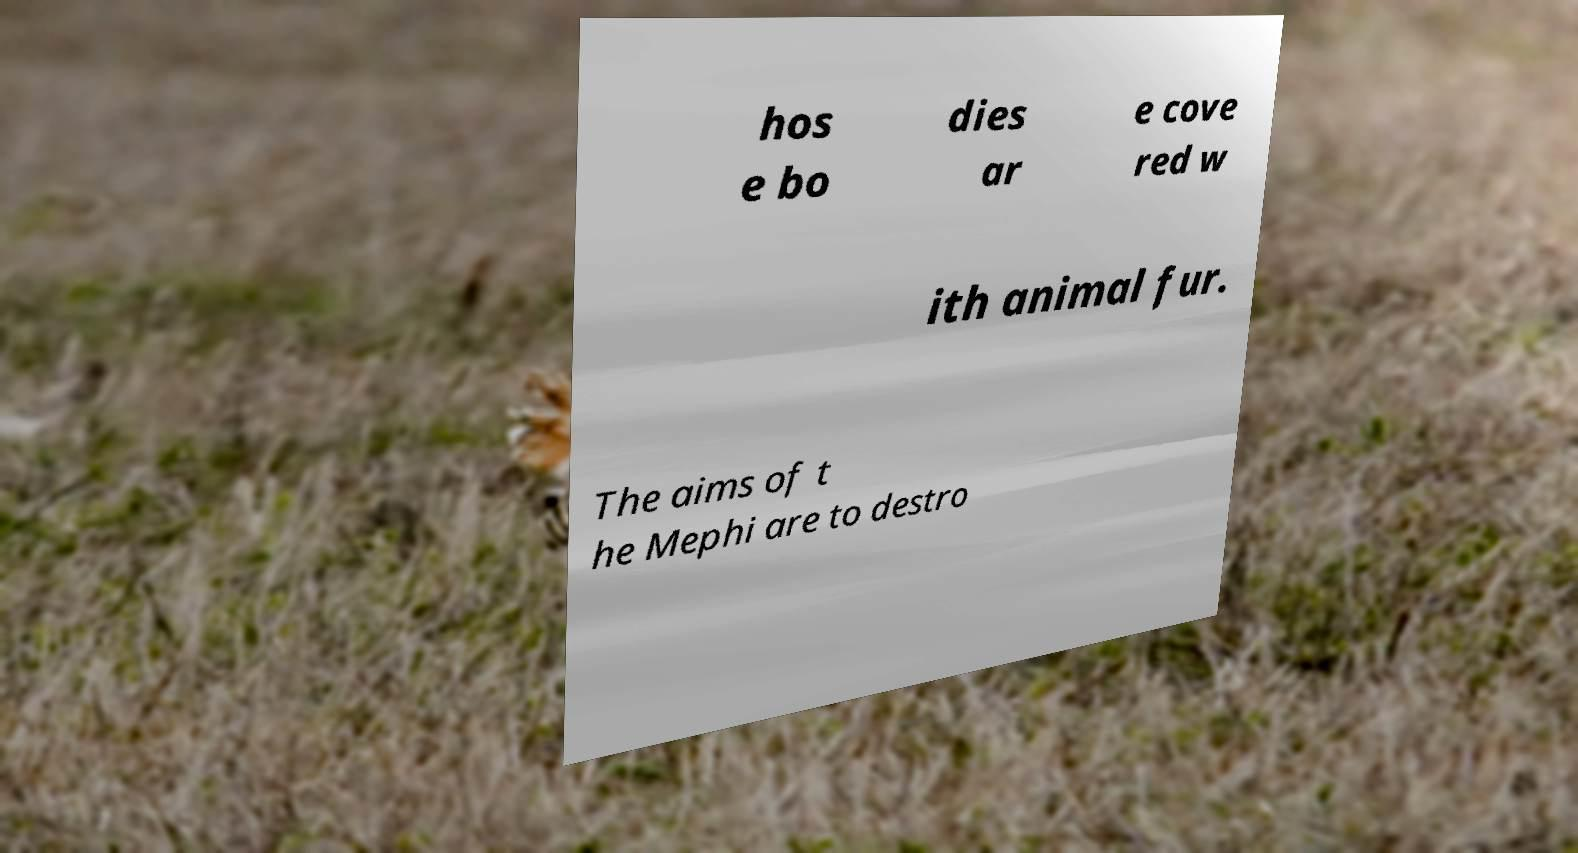What messages or text are displayed in this image? I need them in a readable, typed format. hos e bo dies ar e cove red w ith animal fur. The aims of t he Mephi are to destro 